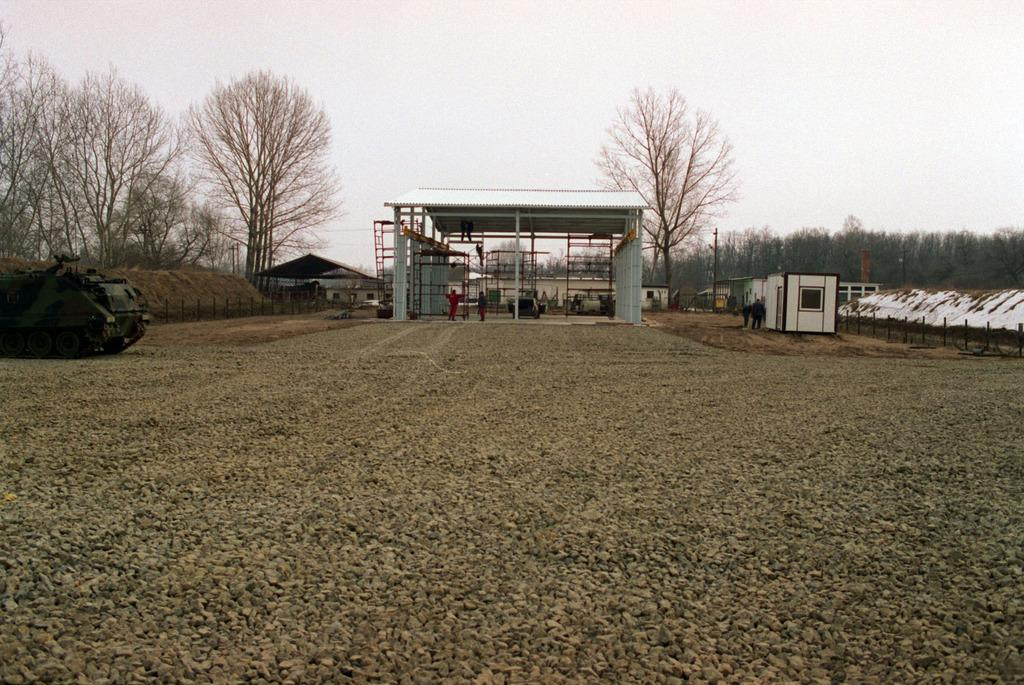How many people are in the image? There is a group of people standing in the image, but the exact number cannot be determined from the provided facts. What is the weather like in the image? There is snow in the image, which suggests a cold and wintry environment. What type of vehicle is in the image? The facts do not specify the type of vehicle in the image. What structures are visible in the image? There are buildings in the image. What type of barrier is present in the image? There is a fence in the image. What type of vegetation is in the image? There are trees in the image. What is visible in the background of the image? The sky is visible in the background of the image. What type of lettuce is being used to write on the fence in the image? There is no lettuce present in the image, and therefore, it cannot be used for writing on the fence. 